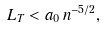Convert formula to latex. <formula><loc_0><loc_0><loc_500><loc_500>L _ { T } < a _ { 0 } \, n ^ { - 5 / 2 } ,</formula> 